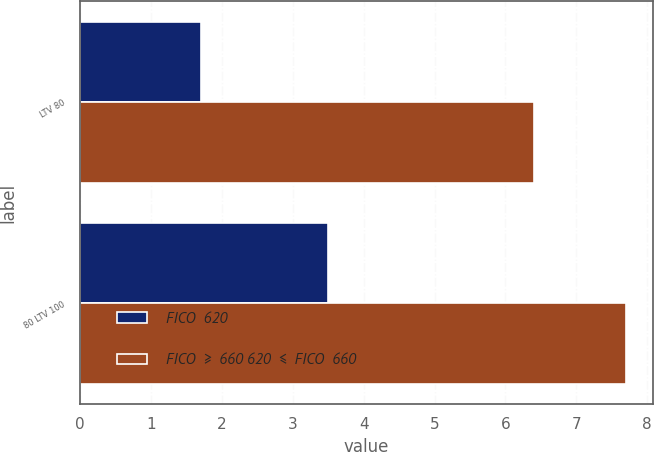Convert chart. <chart><loc_0><loc_0><loc_500><loc_500><stacked_bar_chart><ecel><fcel>LTV 80<fcel>80 LTV 100<nl><fcel>FICO  620<fcel>1.7<fcel>3.5<nl><fcel>FICO  ≥  660 620  ≤  FICO  660<fcel>6.4<fcel>7.7<nl></chart> 